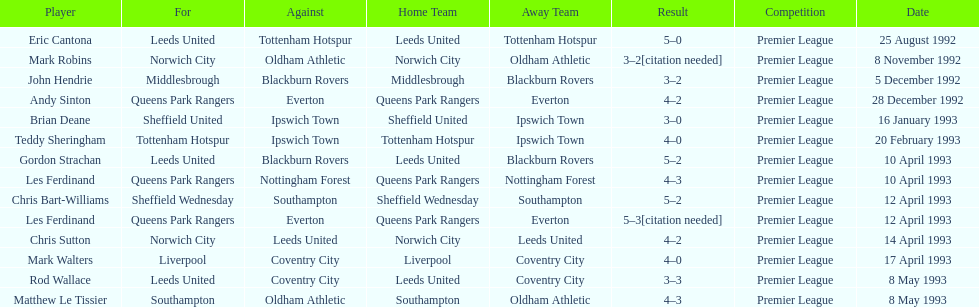Southampton played on may 8th, 1993, who was their opponent? Oldham Athletic. 